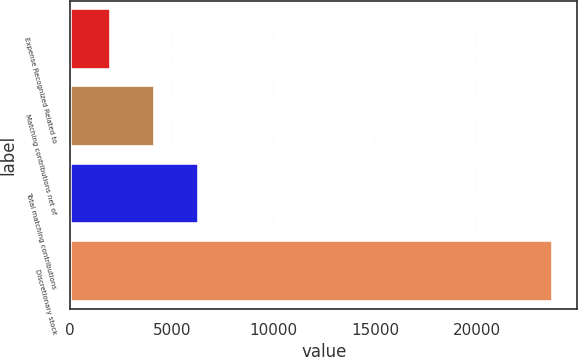Convert chart. <chart><loc_0><loc_0><loc_500><loc_500><bar_chart><fcel>Expense Recognized Related to<fcel>Matching contributions net of<fcel>Total matching contributions<fcel>Discretionary stock<nl><fcel>2012<fcel>4188<fcel>6364<fcel>23772<nl></chart> 